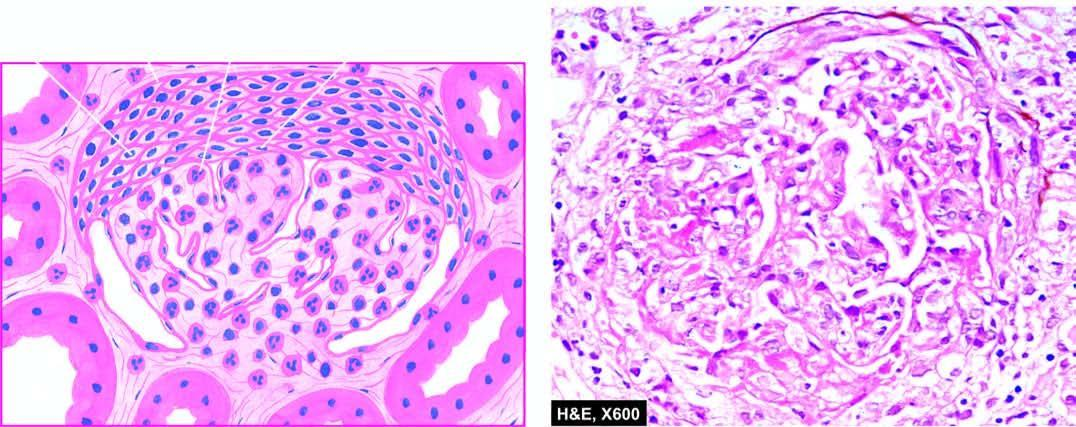does the tuft show hypercellularity and leucocytic infiltration?
Answer the question using a single word or phrase. Yes 